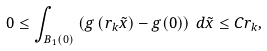Convert formula to latex. <formula><loc_0><loc_0><loc_500><loc_500>0 \leq \int _ { B _ { 1 } ( 0 ) } \left ( g \left ( r _ { k } \tilde { x } \right ) - g ( 0 ) \right ) \, d \tilde { x } \leq C r _ { k } ,</formula> 